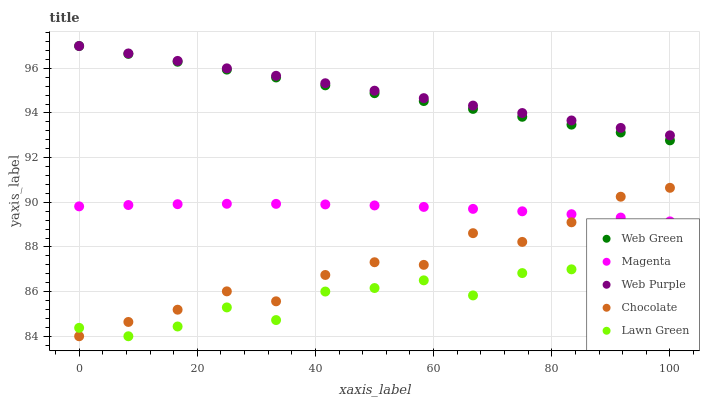Does Lawn Green have the minimum area under the curve?
Answer yes or no. Yes. Does Web Purple have the maximum area under the curve?
Answer yes or no. Yes. Does Magenta have the minimum area under the curve?
Answer yes or no. No. Does Magenta have the maximum area under the curve?
Answer yes or no. No. Is Web Purple the smoothest?
Answer yes or no. Yes. Is Chocolate the roughest?
Answer yes or no. Yes. Is Magenta the smoothest?
Answer yes or no. No. Is Magenta the roughest?
Answer yes or no. No. Does Lawn Green have the lowest value?
Answer yes or no. Yes. Does Magenta have the lowest value?
Answer yes or no. No. Does Web Green have the highest value?
Answer yes or no. Yes. Does Magenta have the highest value?
Answer yes or no. No. Is Chocolate less than Web Purple?
Answer yes or no. Yes. Is Web Green greater than Lawn Green?
Answer yes or no. Yes. Does Web Purple intersect Web Green?
Answer yes or no. Yes. Is Web Purple less than Web Green?
Answer yes or no. No. Is Web Purple greater than Web Green?
Answer yes or no. No. Does Chocolate intersect Web Purple?
Answer yes or no. No. 